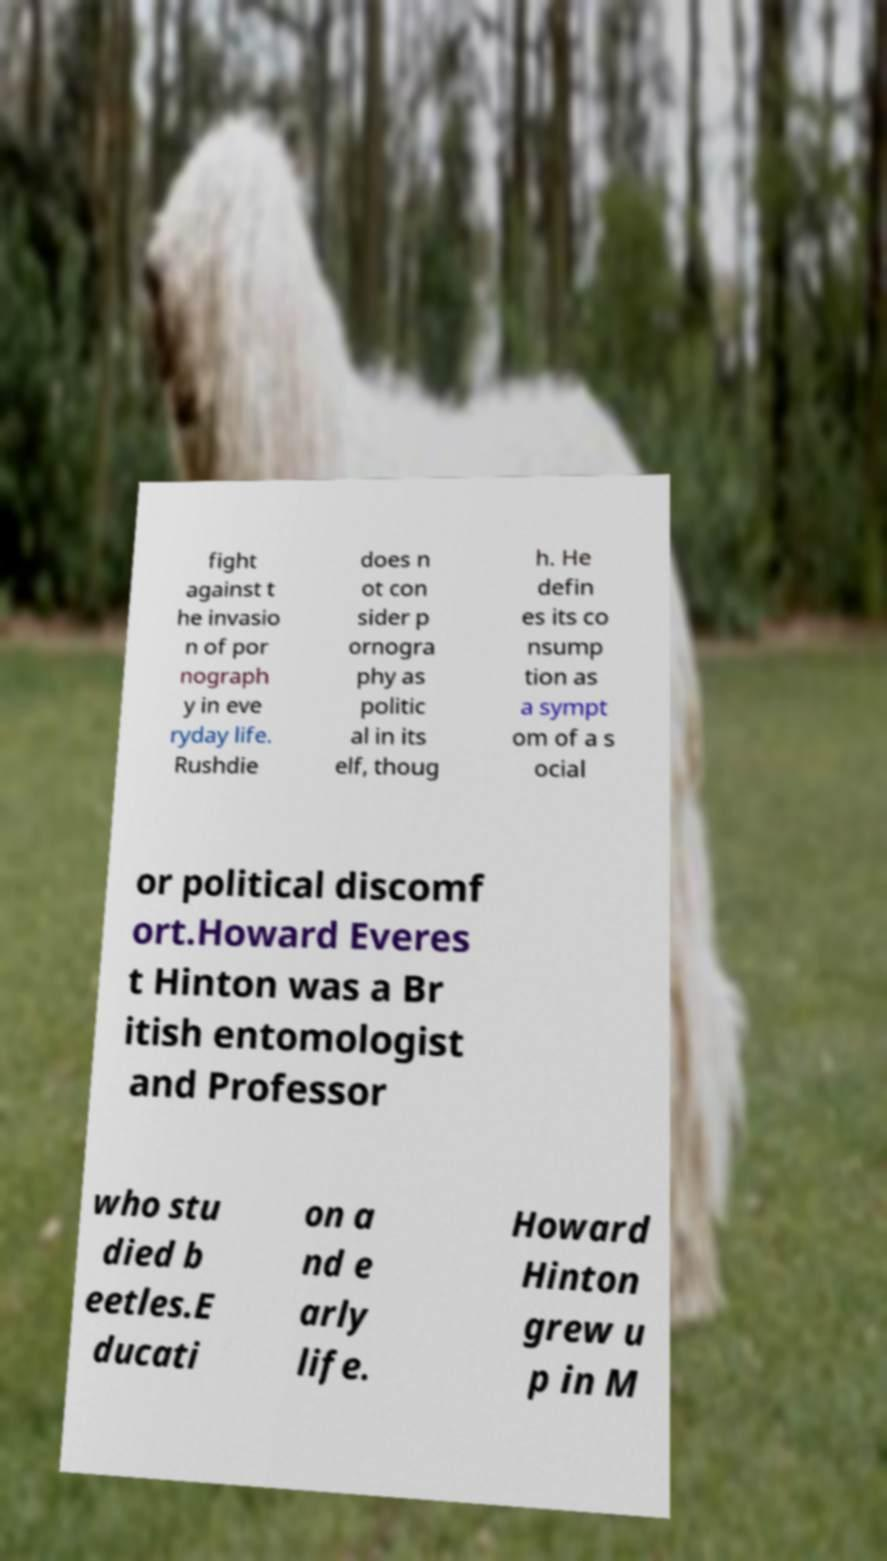Please read and relay the text visible in this image. What does it say? fight against t he invasio n of por nograph y in eve ryday life. Rushdie does n ot con sider p ornogra phy as politic al in its elf, thoug h. He defin es its co nsump tion as a sympt om of a s ocial or political discomf ort.Howard Everes t Hinton was a Br itish entomologist and Professor who stu died b eetles.E ducati on a nd e arly life. Howard Hinton grew u p in M 